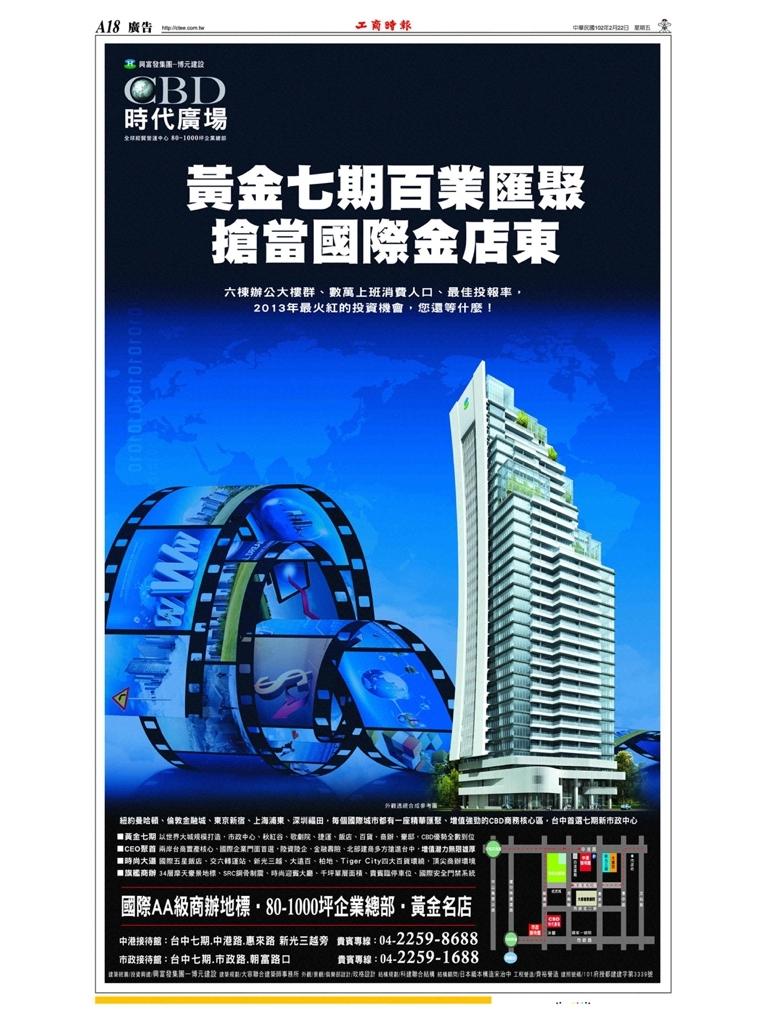What english letters are in the top left corner?
Your answer should be very brief. Cbd. 